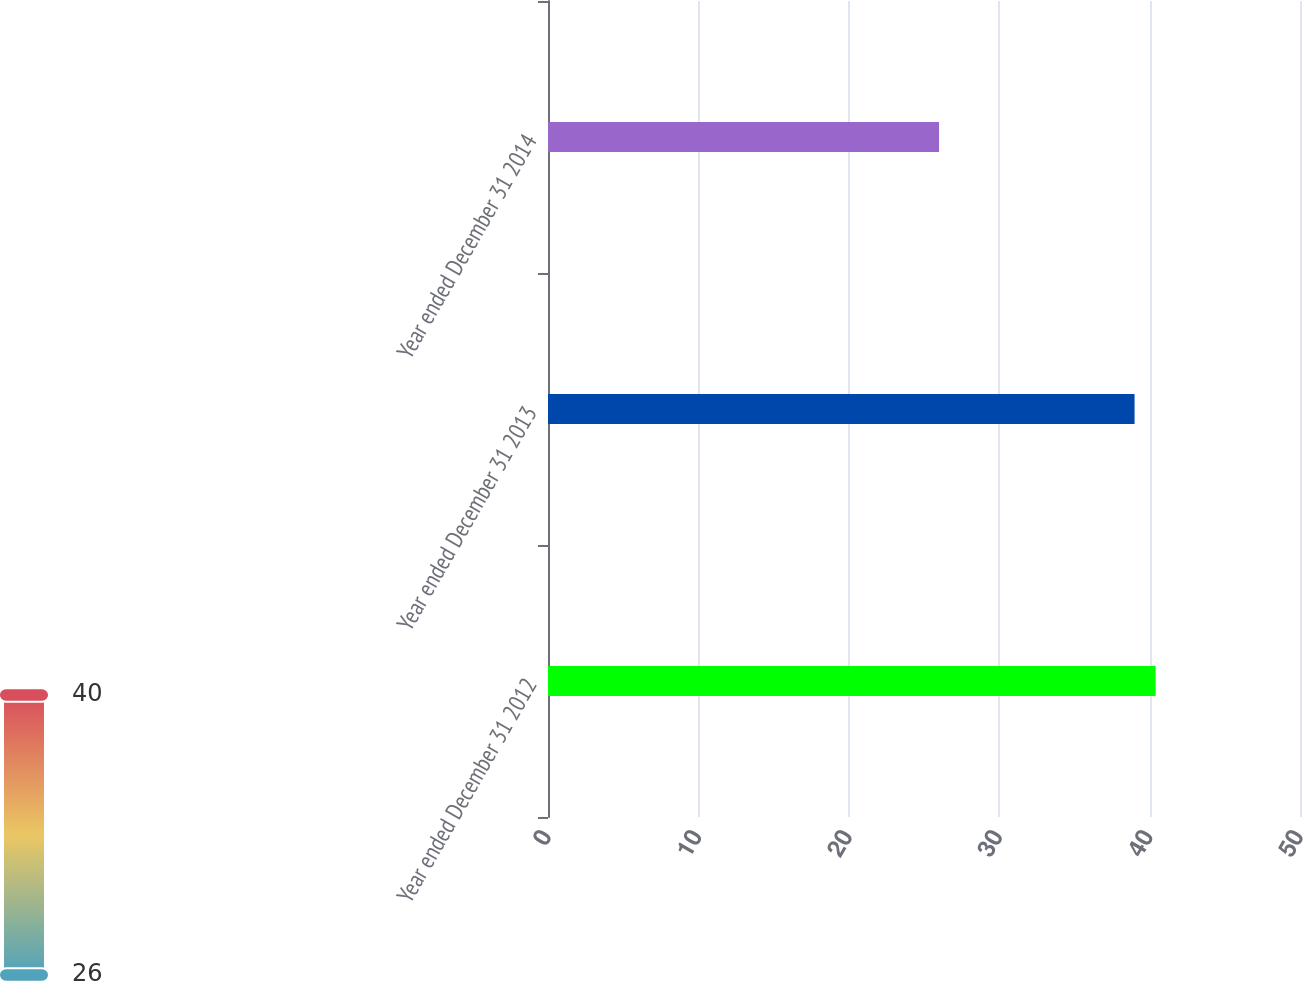Convert chart to OTSL. <chart><loc_0><loc_0><loc_500><loc_500><bar_chart><fcel>Year ended December 31 2012<fcel>Year ended December 31 2013<fcel>Year ended December 31 2014<nl><fcel>40.4<fcel>39<fcel>26<nl></chart> 